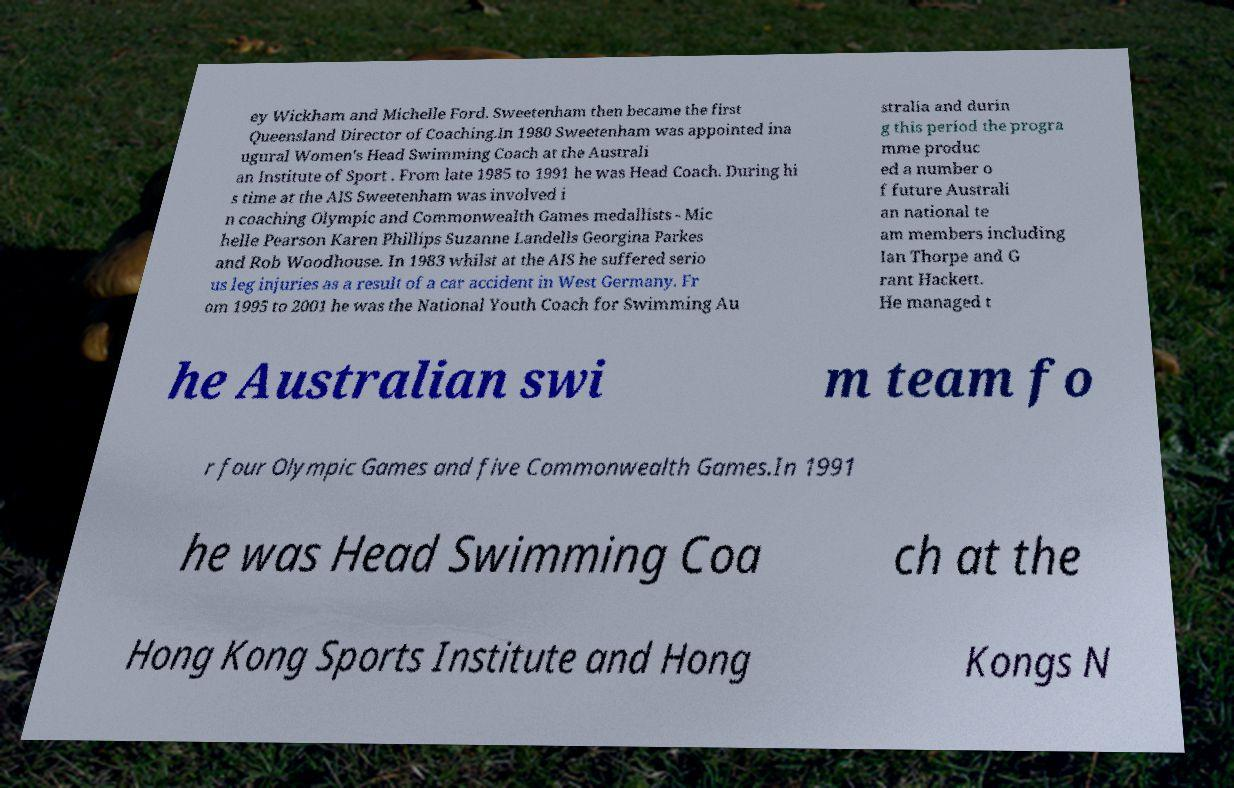I need the written content from this picture converted into text. Can you do that? ey Wickham and Michelle Ford. Sweetenham then became the first Queensland Director of Coaching.In 1980 Sweetenham was appointed ina ugural Women's Head Swimming Coach at the Australi an Institute of Sport . From late 1985 to 1991 he was Head Coach. During hi s time at the AIS Sweetenham was involved i n coaching Olympic and Commonwealth Games medallists - Mic helle Pearson Karen Phillips Suzanne Landells Georgina Parkes and Rob Woodhouse. In 1983 whilst at the AIS he suffered serio us leg injuries as a result of a car accident in West Germany. Fr om 1995 to 2001 he was the National Youth Coach for Swimming Au stralia and durin g this period the progra mme produc ed a number o f future Australi an national te am members including Ian Thorpe and G rant Hackett. He managed t he Australian swi m team fo r four Olympic Games and five Commonwealth Games.In 1991 he was Head Swimming Coa ch at the Hong Kong Sports Institute and Hong Kongs N 